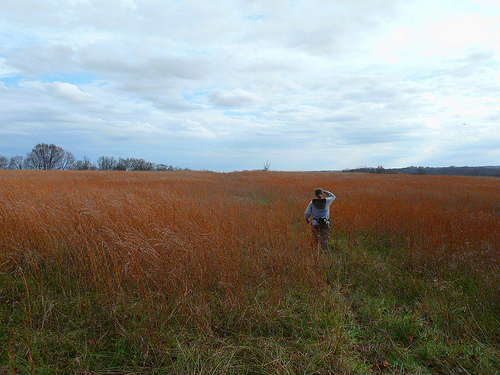<image>
Is the man on the grass? Yes. Looking at the image, I can see the man is positioned on top of the grass, with the grass providing support. 